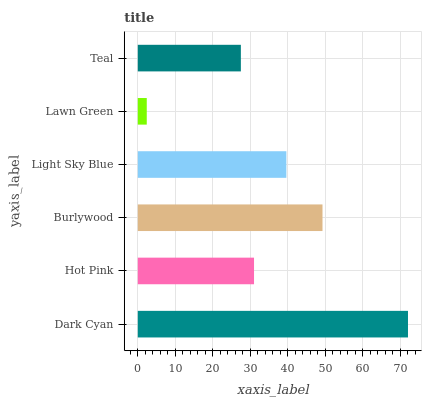Is Lawn Green the minimum?
Answer yes or no. Yes. Is Dark Cyan the maximum?
Answer yes or no. Yes. Is Hot Pink the minimum?
Answer yes or no. No. Is Hot Pink the maximum?
Answer yes or no. No. Is Dark Cyan greater than Hot Pink?
Answer yes or no. Yes. Is Hot Pink less than Dark Cyan?
Answer yes or no. Yes. Is Hot Pink greater than Dark Cyan?
Answer yes or no. No. Is Dark Cyan less than Hot Pink?
Answer yes or no. No. Is Light Sky Blue the high median?
Answer yes or no. Yes. Is Hot Pink the low median?
Answer yes or no. Yes. Is Lawn Green the high median?
Answer yes or no. No. Is Lawn Green the low median?
Answer yes or no. No. 